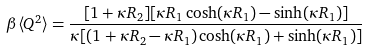<formula> <loc_0><loc_0><loc_500><loc_500>\beta \langle Q ^ { 2 } \rangle = \frac { [ 1 + \kappa R _ { 2 } ] [ \kappa R _ { 1 } \cosh ( \kappa R _ { 1 } ) - \sinh ( \kappa R _ { 1 } ) ] } { \kappa [ ( 1 + \kappa R _ { 2 } - \kappa R _ { 1 } ) \cosh ( \kappa R _ { 1 } ) + \sinh ( \kappa R _ { 1 } ) ] }</formula> 